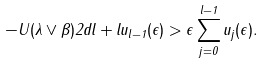Convert formula to latex. <formula><loc_0><loc_0><loc_500><loc_500>- U ( \lambda \vee \beta ) 2 d l + l u _ { l - 1 } ( \epsilon ) > \epsilon \sum _ { j = 0 } ^ { l - 1 } u _ { j } ( \epsilon ) .</formula> 